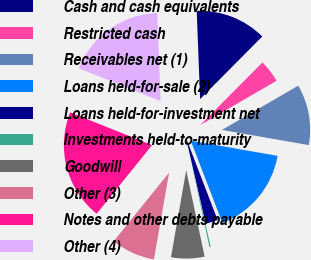Convert chart to OTSL. <chart><loc_0><loc_0><loc_500><loc_500><pie_chart><fcel>Cash and cash equivalents<fcel>Restricted cash<fcel>Receivables net (1)<fcel>Loans held-for-sale (2)<fcel>Loans held-for-investment net<fcel>Investments held-to-maturity<fcel>Goodwill<fcel>Other (3)<fcel>Notes and other debts payable<fcel>Other (4)<nl><fcel>13.06%<fcel>4.19%<fcel>11.13%<fcel>16.4%<fcel>2.26%<fcel>0.23%<fcel>6.12%<fcel>8.05%<fcel>20.26%<fcel>18.33%<nl></chart> 